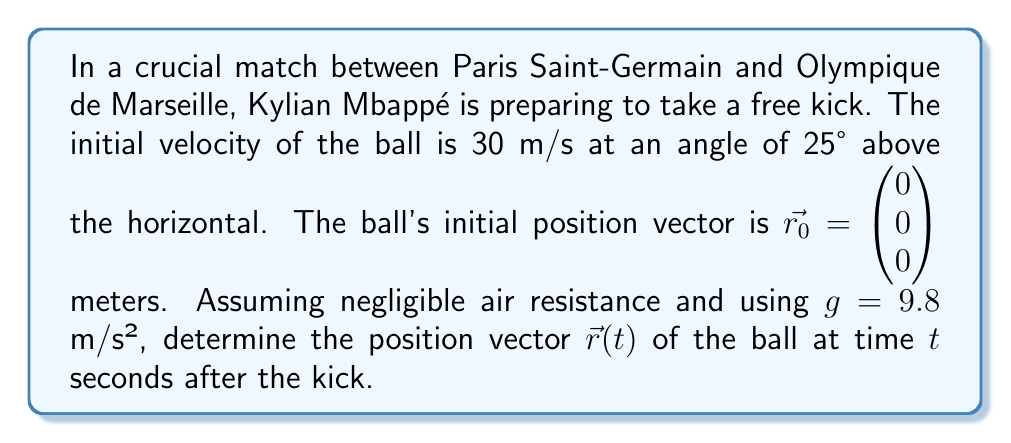Provide a solution to this math problem. To solve this problem, we'll use the equations of motion for projectile motion and express them as a vector equation.

Step 1: Determine the initial velocity components
$$v_0x = v_0 \cos\theta = 30 \cos(25°) = 27.19 \text{ m/s}$$
$$v_0y = v_0 \sin\theta = 30 \sin(25°) = 12.68 \text{ m/s}$$

Step 2: Express the position vector as a function of time
The position vector $\vec{r}(t)$ can be written as:

$$\vec{r}(t) = \begin{pmatrix} x(t) \\ y(t) \\ z(t) \end{pmatrix}$$

where:
$$x(t) = x_0 + v_0x \cdot t$$
$$y(t) = y_0 + v_0y \cdot t - \frac{1}{2}gt^2$$
$$z(t) = 0$$ (assuming the kick is in the xy-plane)

Step 3: Substitute the known values
$$x(t) = 0 + 27.19t$$
$$y(t) = 0 + 12.68t - \frac{1}{2}(9.8)t^2$$
$$z(t) = 0$$

Step 4: Simplify and write the final position vector
$$\vec{r}(t) = \begin{pmatrix} 27.19t \\ 12.68t - 4.9t^2 \\ 0 \end{pmatrix}$$
Answer: $$\vec{r}(t) = \begin{pmatrix} 27.19t \\ 12.68t - 4.9t^2 \\ 0 \end{pmatrix}$$ 